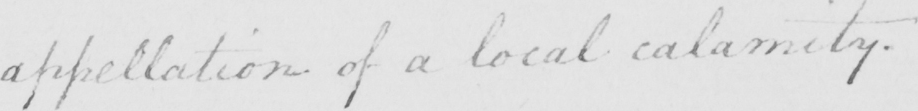Can you tell me what this handwritten text says? appellation of a local calamity . 